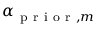Convert formula to latex. <formula><loc_0><loc_0><loc_500><loc_500>\alpha _ { p r i o r , m }</formula> 